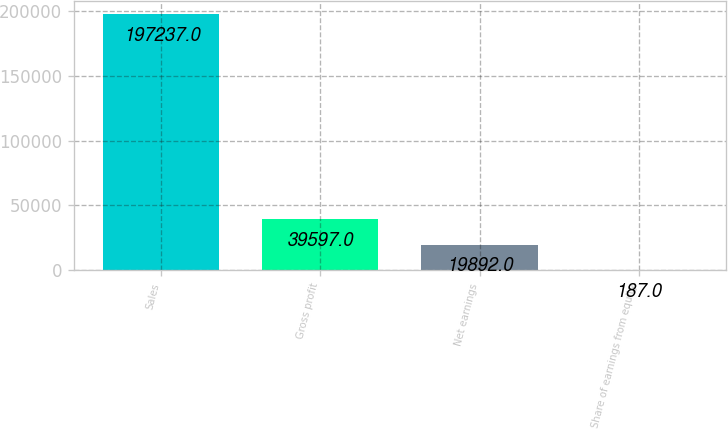Convert chart. <chart><loc_0><loc_0><loc_500><loc_500><bar_chart><fcel>Sales<fcel>Gross profit<fcel>Net earnings<fcel>Share of earnings from equity<nl><fcel>197237<fcel>39597<fcel>19892<fcel>187<nl></chart> 